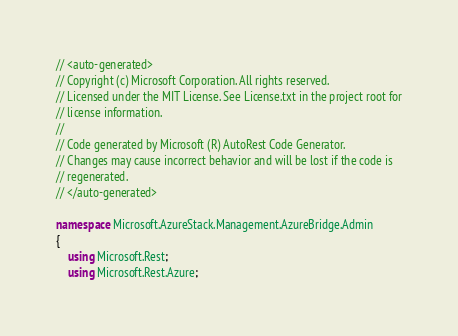Convert code to text. <code><loc_0><loc_0><loc_500><loc_500><_C#_>// <auto-generated>
// Copyright (c) Microsoft Corporation. All rights reserved.
// Licensed under the MIT License. See License.txt in the project root for
// license information.
//
// Code generated by Microsoft (R) AutoRest Code Generator.
// Changes may cause incorrect behavior and will be lost if the code is
// regenerated.
// </auto-generated>

namespace Microsoft.AzureStack.Management.AzureBridge.Admin
{
    using Microsoft.Rest;
    using Microsoft.Rest.Azure;</code> 